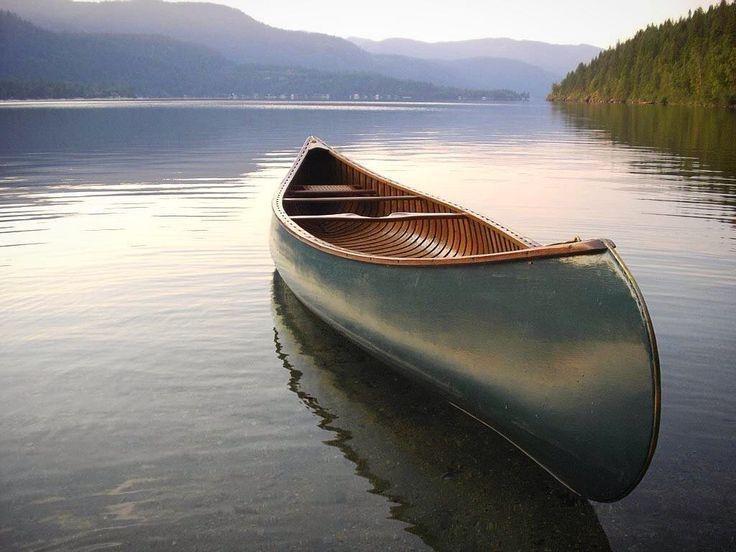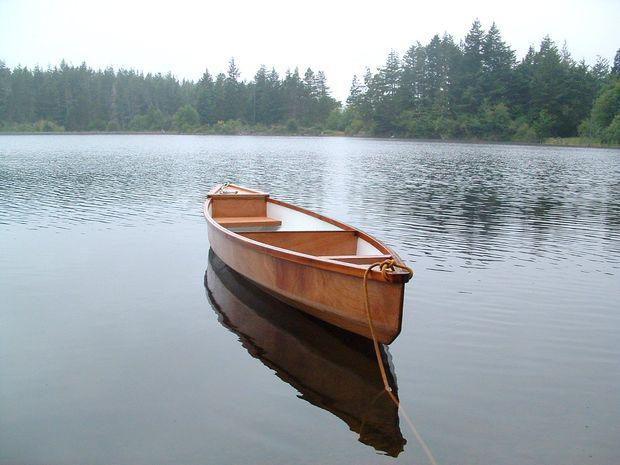The first image is the image on the left, the second image is the image on the right. Analyze the images presented: Is the assertion "Both images contain a canoe that is turned toward the right side of the photo." valid? Answer yes or no. Yes. 